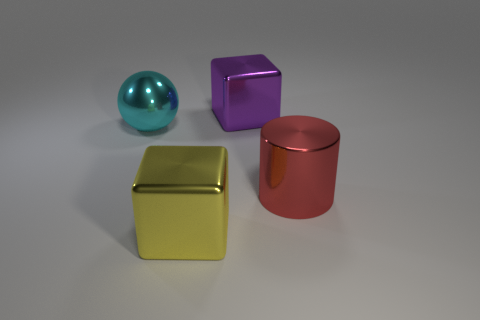There is a thing right of the cube that is right of the yellow cube; how many metallic objects are in front of it?
Ensure brevity in your answer.  1. How many big shiny things are both behind the large metal cylinder and left of the large purple shiny thing?
Make the answer very short. 1. Is the number of shiny objects that are behind the large cyan thing greater than the number of red matte things?
Offer a very short reply. Yes. How many purple things are the same size as the cyan metal thing?
Ensure brevity in your answer.  1. What number of large things are either shiny things or purple objects?
Make the answer very short. 4. What number of big cylinders are there?
Keep it short and to the point. 1. Is the number of big red metal cylinders that are in front of the large purple cube the same as the number of large red things that are in front of the large cyan object?
Provide a succinct answer. Yes. Are there any metal things in front of the large purple thing?
Offer a very short reply. Yes. There is a large metal cube behind the yellow cube; what color is it?
Offer a terse response. Purple. What material is the big block left of the large object that is behind the big cyan object?
Provide a succinct answer. Metal. 